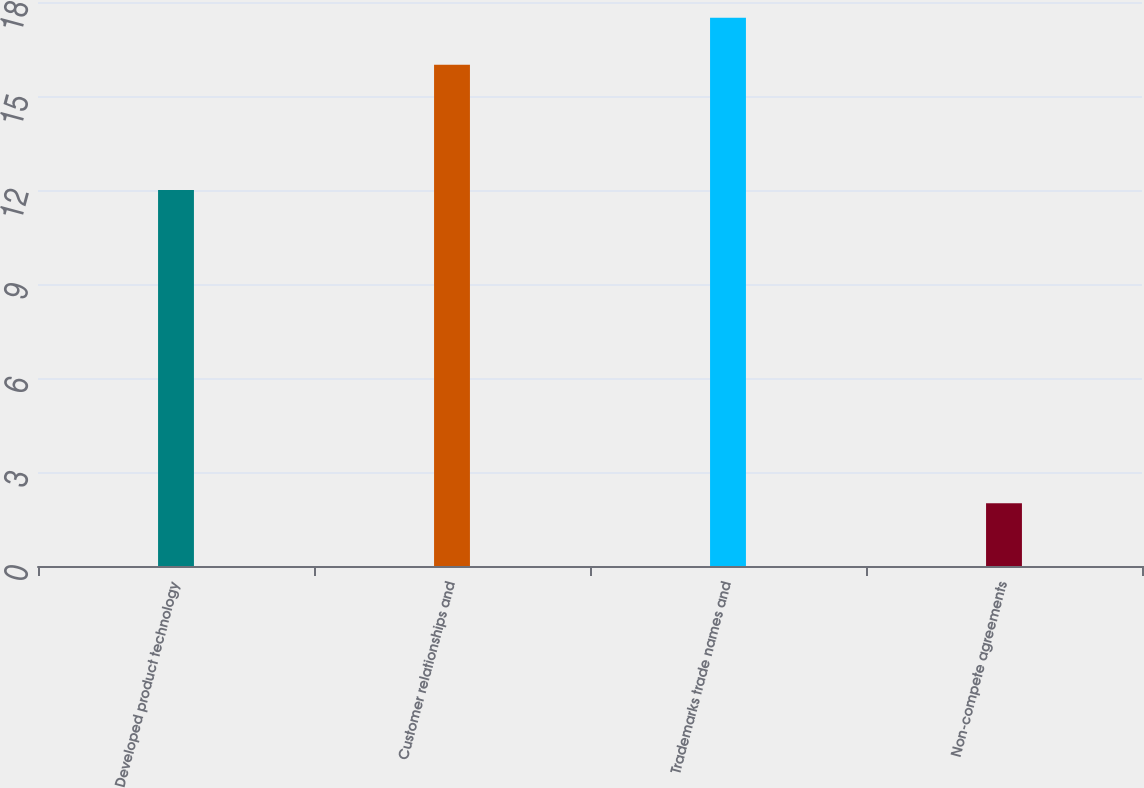<chart> <loc_0><loc_0><loc_500><loc_500><bar_chart><fcel>Developed product technology<fcel>Customer relationships and<fcel>Trademarks trade names and<fcel>Non-compete agreements<nl><fcel>12<fcel>16<fcel>17.5<fcel>2<nl></chart> 